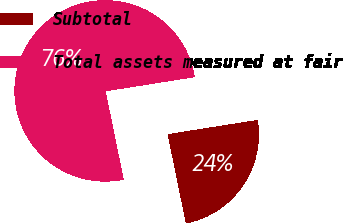<chart> <loc_0><loc_0><loc_500><loc_500><pie_chart><fcel>Subtotal<fcel>Total assets measured at fair<nl><fcel>24.29%<fcel>75.71%<nl></chart> 